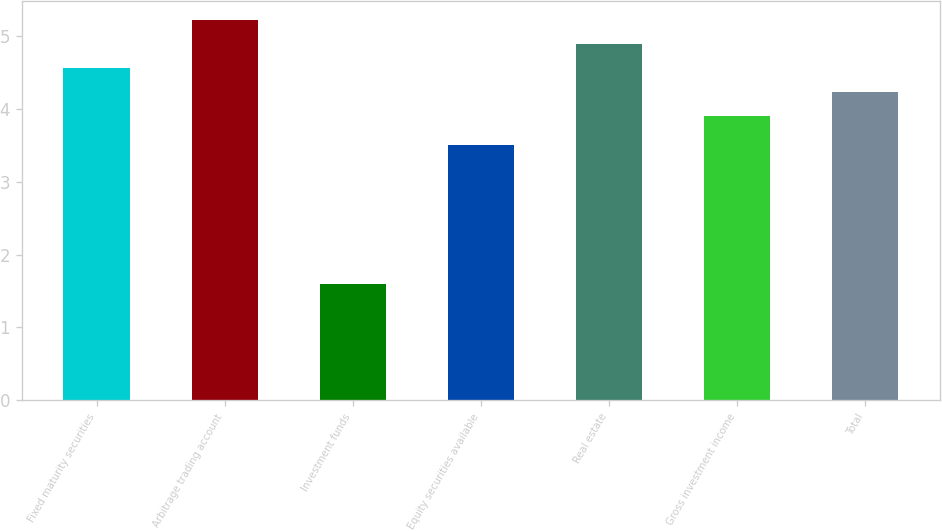Convert chart to OTSL. <chart><loc_0><loc_0><loc_500><loc_500><bar_chart><fcel>Fixed maturity securities<fcel>Arbitrage trading account<fcel>Investment funds<fcel>Equity securities available<fcel>Real estate<fcel>Gross investment income<fcel>Total<nl><fcel>4.56<fcel>5.22<fcel>1.6<fcel>3.5<fcel>4.89<fcel>3.9<fcel>4.23<nl></chart> 